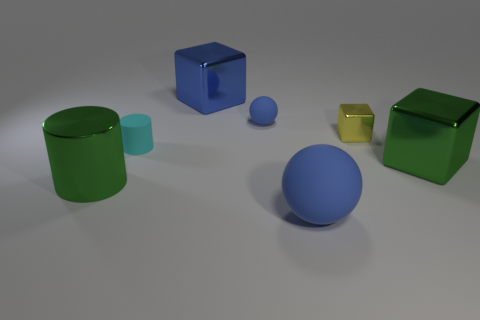What number of things are blue rubber balls or tiny cyan things?
Your response must be concise. 3. Do the big green metal thing that is behind the large green metallic cylinder and the small cyan thing that is left of the tiny yellow thing have the same shape?
Give a very brief answer. No. What number of things are both to the left of the green cube and behind the large ball?
Your answer should be compact. 5. How many other things are there of the same size as the yellow thing?
Your answer should be very brief. 2. There is a object that is in front of the tiny yellow metal object and right of the big blue matte sphere; what material is it made of?
Provide a succinct answer. Metal. There is a big rubber object; is it the same color as the matte object behind the tiny cyan cylinder?
Offer a very short reply. Yes. What size is the other blue rubber thing that is the same shape as the large rubber object?
Provide a succinct answer. Small. What is the shape of the big thing that is both on the left side of the tiny sphere and in front of the large blue metallic block?
Offer a terse response. Cylinder. There is a yellow shiny block; is it the same size as the matte object on the left side of the blue metal object?
Provide a succinct answer. Yes. The big matte thing that is the same shape as the tiny blue rubber thing is what color?
Your answer should be very brief. Blue. 